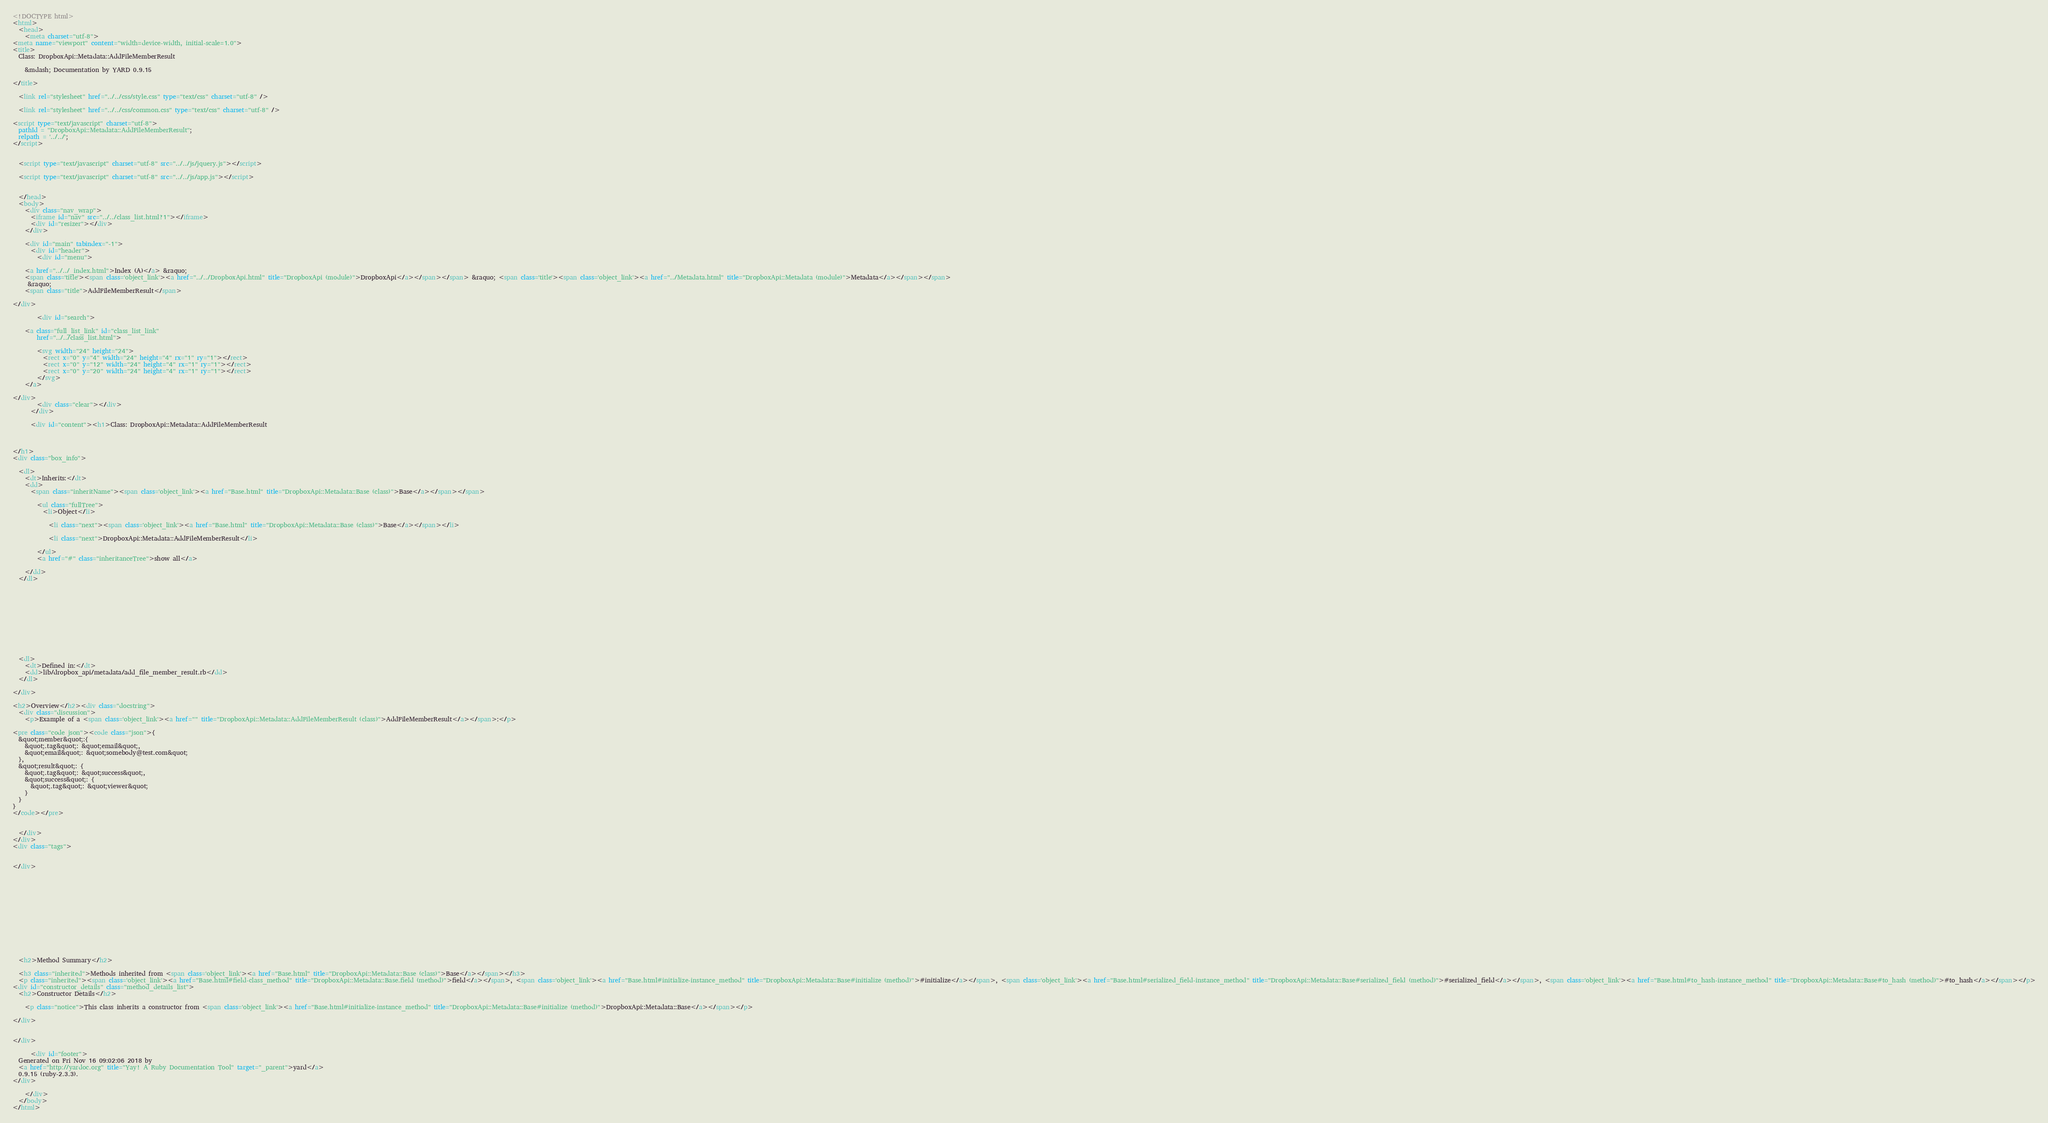Convert code to text. <code><loc_0><loc_0><loc_500><loc_500><_HTML_><!DOCTYPE html>
<html>
  <head>
    <meta charset="utf-8">
<meta name="viewport" content="width=device-width, initial-scale=1.0">
<title>
  Class: DropboxApi::Metadata::AddFileMemberResult
  
    &mdash; Documentation by YARD 0.9.15
  
</title>

  <link rel="stylesheet" href="../../css/style.css" type="text/css" charset="utf-8" />

  <link rel="stylesheet" href="../../css/common.css" type="text/css" charset="utf-8" />

<script type="text/javascript" charset="utf-8">
  pathId = "DropboxApi::Metadata::AddFileMemberResult";
  relpath = '../../';
</script>


  <script type="text/javascript" charset="utf-8" src="../../js/jquery.js"></script>

  <script type="text/javascript" charset="utf-8" src="../../js/app.js"></script>


  </head>
  <body>
    <div class="nav_wrap">
      <iframe id="nav" src="../../class_list.html?1"></iframe>
      <div id="resizer"></div>
    </div>

    <div id="main" tabindex="-1">
      <div id="header">
        <div id="menu">
  
    <a href="../../_index.html">Index (A)</a> &raquo;
    <span class='title'><span class='object_link'><a href="../../DropboxApi.html" title="DropboxApi (module)">DropboxApi</a></span></span> &raquo; <span class='title'><span class='object_link'><a href="../Metadata.html" title="DropboxApi::Metadata (module)">Metadata</a></span></span>
     &raquo; 
    <span class="title">AddFileMemberResult</span>
  
</div>

        <div id="search">
  
    <a class="full_list_link" id="class_list_link"
        href="../../class_list.html">

        <svg width="24" height="24">
          <rect x="0" y="4" width="24" height="4" rx="1" ry="1"></rect>
          <rect x="0" y="12" width="24" height="4" rx="1" ry="1"></rect>
          <rect x="0" y="20" width="24" height="4" rx="1" ry="1"></rect>
        </svg>
    </a>
  
</div>
        <div class="clear"></div>
      </div>

      <div id="content"><h1>Class: DropboxApi::Metadata::AddFileMemberResult
  
  
  
</h1>
<div class="box_info">
  
  <dl>
    <dt>Inherits:</dt>
    <dd>
      <span class="inheritName"><span class='object_link'><a href="Base.html" title="DropboxApi::Metadata::Base (class)">Base</a></span></span>
      
        <ul class="fullTree">
          <li>Object</li>
          
            <li class="next"><span class='object_link'><a href="Base.html" title="DropboxApi::Metadata::Base (class)">Base</a></span></li>
          
            <li class="next">DropboxApi::Metadata::AddFileMemberResult</li>
          
        </ul>
        <a href="#" class="inheritanceTree">show all</a>
      
    </dd>
  </dl>
  

  
  
  
  
  

  

  
  <dl>
    <dt>Defined in:</dt>
    <dd>lib/dropbox_api/metadata/add_file_member_result.rb</dd>
  </dl>
  
</div>

<h2>Overview</h2><div class="docstring">
  <div class="discussion">
    <p>Example of a <span class='object_link'><a href="" title="DropboxApi::Metadata::AddFileMemberResult (class)">AddFileMemberResult</a></span>:</p>

<pre class="code json"><code class="json">{
  &quot;member&quot;:{
    &quot;.tag&quot;: &quot;email&quot;,
    &quot;email&quot;: &quot;somebody@test.com&quot;
  },
  &quot;result&quot;: {
    &quot;.tag&quot;: &quot;success&quot;,
    &quot;success&quot;: {
      &quot;.tag&quot;: &quot;viewer&quot;
    }
  }
}
</code></pre>


  </div>
</div>
<div class="tags">
  

</div>







  
  
  
  
  
  
  <h2>Method Summary</h2>
  
  <h3 class="inherited">Methods inherited from <span class='object_link'><a href="Base.html" title="DropboxApi::Metadata::Base (class)">Base</a></span></h3>
  <p class="inherited"><span class='object_link'><a href="Base.html#field-class_method" title="DropboxApi::Metadata::Base.field (method)">field</a></span>, <span class='object_link'><a href="Base.html#initialize-instance_method" title="DropboxApi::Metadata::Base#initialize (method)">#initialize</a></span>, <span class='object_link'><a href="Base.html#serialized_field-instance_method" title="DropboxApi::Metadata::Base#serialized_field (method)">#serialized_field</a></span>, <span class='object_link'><a href="Base.html#to_hash-instance_method" title="DropboxApi::Metadata::Base#to_hash (method)">#to_hash</a></span></p>
<div id="constructor_details" class="method_details_list">
  <h2>Constructor Details</h2>
  
    <p class="notice">This class inherits a constructor from <span class='object_link'><a href="Base.html#initialize-instance_method" title="DropboxApi::Metadata::Base#initialize (method)">DropboxApi::Metadata::Base</a></span></p>
  
</div>


</div>

      <div id="footer">
  Generated on Fri Nov 16 09:02:06 2018 by
  <a href="http://yardoc.org" title="Yay! A Ruby Documentation Tool" target="_parent">yard</a>
  0.9.15 (ruby-2.3.3).
</div>

    </div>
  </body>
</html></code> 